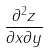Convert formula to latex. <formula><loc_0><loc_0><loc_500><loc_500>\frac { \partial ^ { 2 } z } { \partial x \partial y }</formula> 